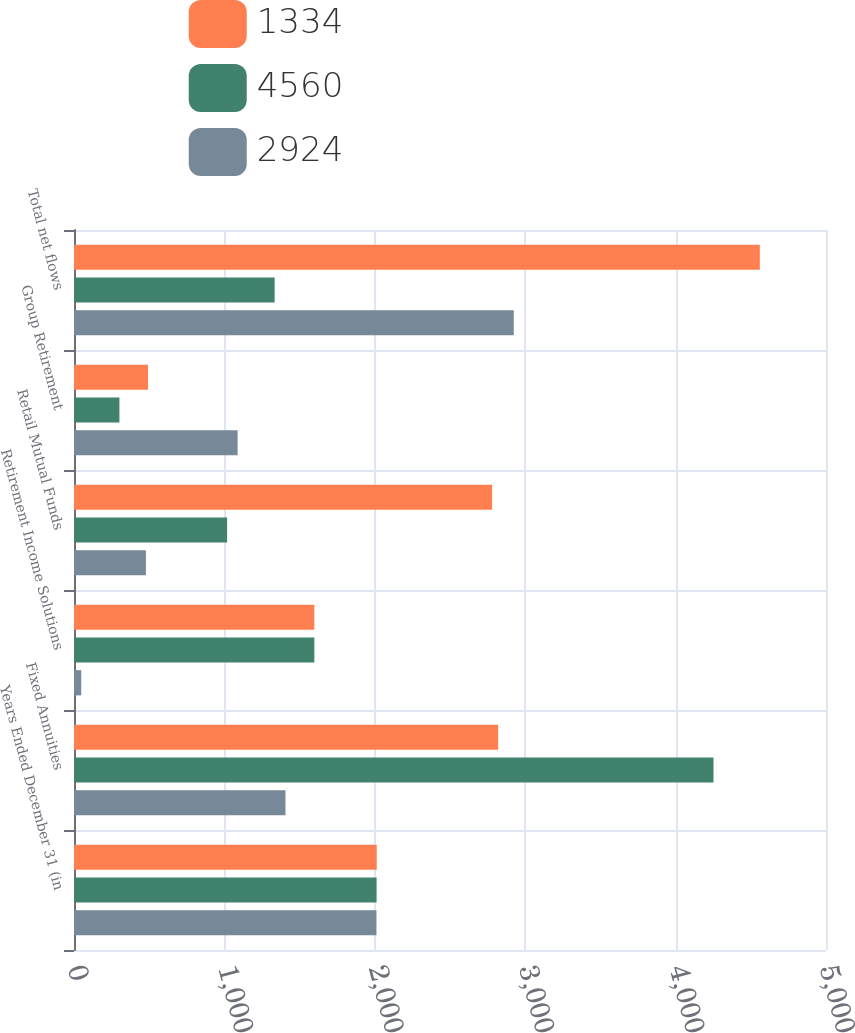Convert chart to OTSL. <chart><loc_0><loc_0><loc_500><loc_500><stacked_bar_chart><ecel><fcel>Years Ended December 31 (in<fcel>Fixed Annuities<fcel>Retirement Income Solutions<fcel>Retail Mutual Funds<fcel>Group Retirement<fcel>Total net flows<nl><fcel>1334<fcel>2013<fcel>2820<fcel>1598<fcel>2780<fcel>492<fcel>4560<nl><fcel>4560<fcel>2012<fcel>4252<fcel>1598<fcel>1018<fcel>302<fcel>1334<nl><fcel>2924<fcel>2011<fcel>1406<fcel>48<fcel>478<fcel>1088<fcel>2924<nl></chart> 